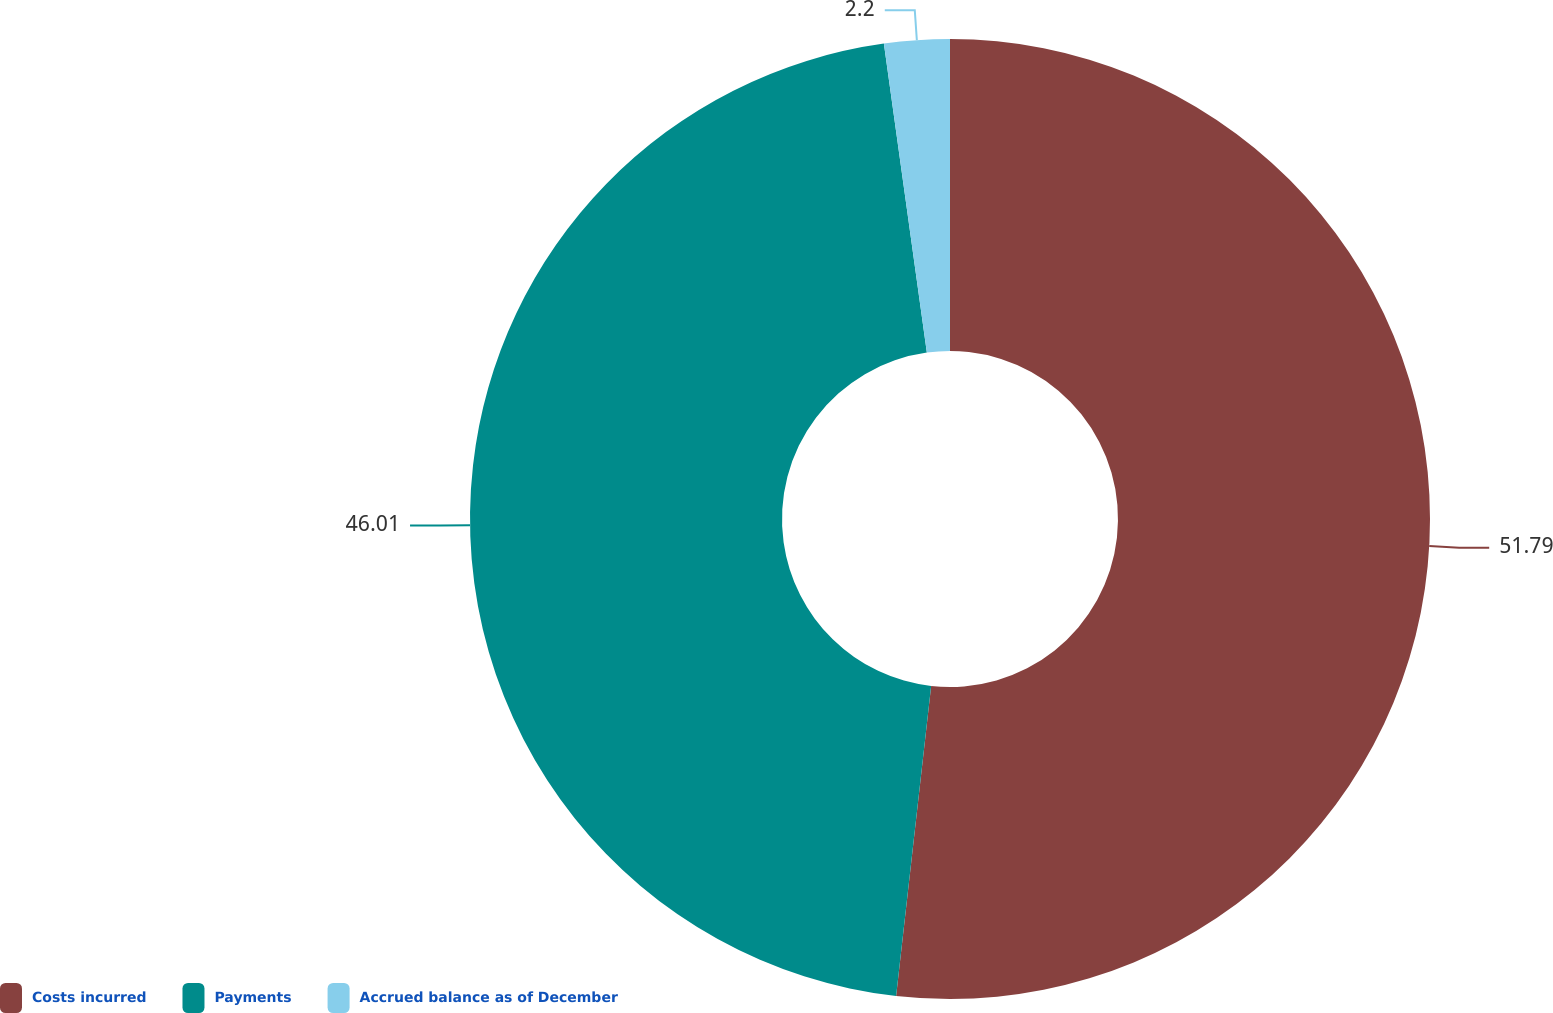Convert chart to OTSL. <chart><loc_0><loc_0><loc_500><loc_500><pie_chart><fcel>Costs incurred<fcel>Payments<fcel>Accrued balance as of December<nl><fcel>51.79%<fcel>46.01%<fcel>2.2%<nl></chart> 